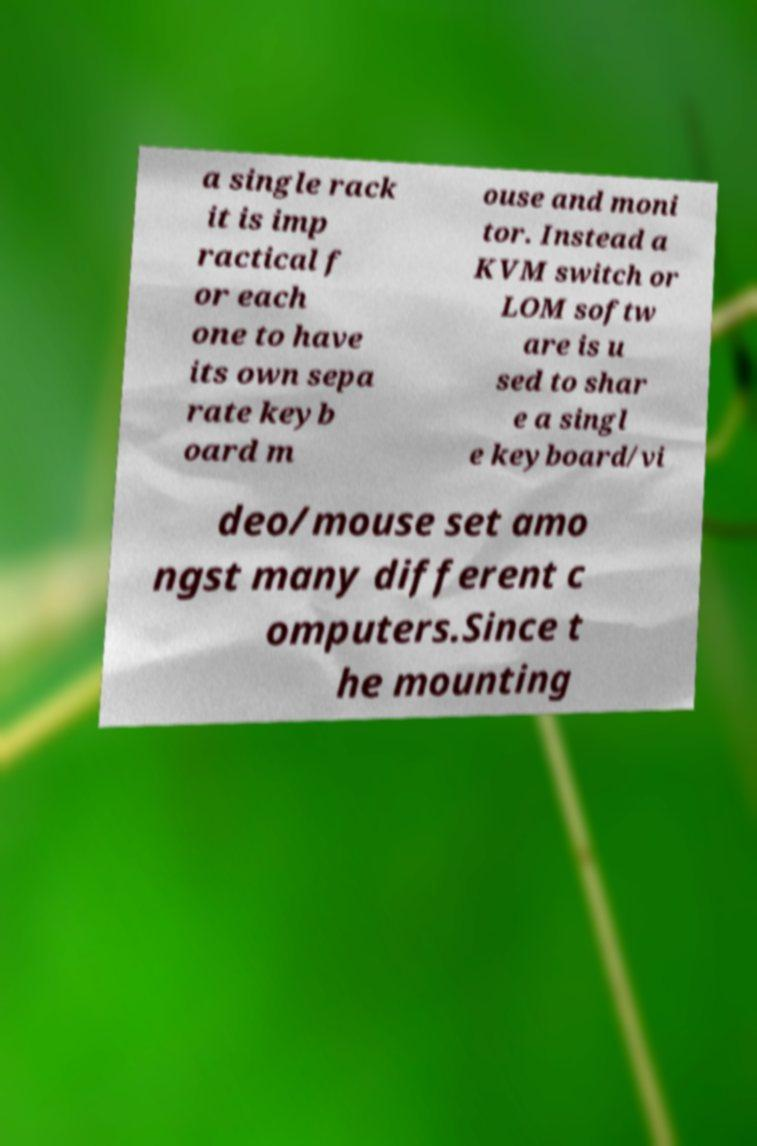Can you read and provide the text displayed in the image?This photo seems to have some interesting text. Can you extract and type it out for me? a single rack it is imp ractical f or each one to have its own sepa rate keyb oard m ouse and moni tor. Instead a KVM switch or LOM softw are is u sed to shar e a singl e keyboard/vi deo/mouse set amo ngst many different c omputers.Since t he mounting 